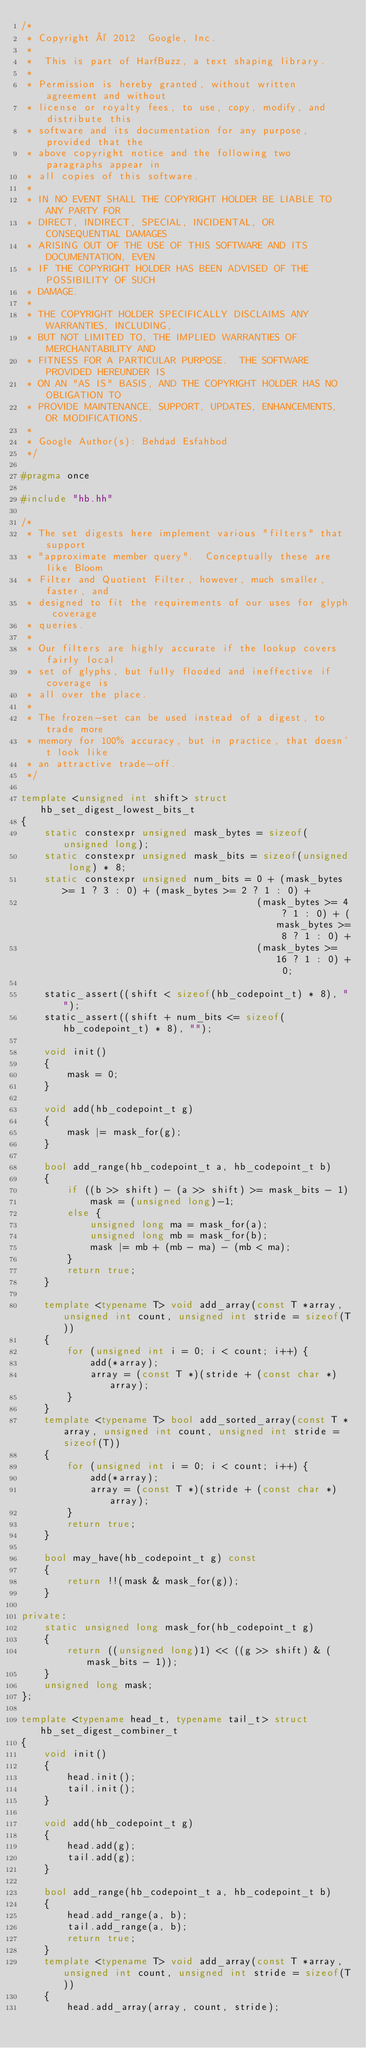Convert code to text. <code><loc_0><loc_0><loc_500><loc_500><_C++_>/*
 * Copyright © 2012  Google, Inc.
 *
 *  This is part of HarfBuzz, a text shaping library.
 *
 * Permission is hereby granted, without written agreement and without
 * license or royalty fees, to use, copy, modify, and distribute this
 * software and its documentation for any purpose, provided that the
 * above copyright notice and the following two paragraphs appear in
 * all copies of this software.
 *
 * IN NO EVENT SHALL THE COPYRIGHT HOLDER BE LIABLE TO ANY PARTY FOR
 * DIRECT, INDIRECT, SPECIAL, INCIDENTAL, OR CONSEQUENTIAL DAMAGES
 * ARISING OUT OF THE USE OF THIS SOFTWARE AND ITS DOCUMENTATION, EVEN
 * IF THE COPYRIGHT HOLDER HAS BEEN ADVISED OF THE POSSIBILITY OF SUCH
 * DAMAGE.
 *
 * THE COPYRIGHT HOLDER SPECIFICALLY DISCLAIMS ANY WARRANTIES, INCLUDING,
 * BUT NOT LIMITED TO, THE IMPLIED WARRANTIES OF MERCHANTABILITY AND
 * FITNESS FOR A PARTICULAR PURPOSE.  THE SOFTWARE PROVIDED HEREUNDER IS
 * ON AN "AS IS" BASIS, AND THE COPYRIGHT HOLDER HAS NO OBLIGATION TO
 * PROVIDE MAINTENANCE, SUPPORT, UPDATES, ENHANCEMENTS, OR MODIFICATIONS.
 *
 * Google Author(s): Behdad Esfahbod
 */

#pragma once

#include "hb.hh"

/*
 * The set digests here implement various "filters" that support
 * "approximate member query".  Conceptually these are like Bloom
 * Filter and Quotient Filter, however, much smaller, faster, and
 * designed to fit the requirements of our uses for glyph coverage
 * queries.
 *
 * Our filters are highly accurate if the lookup covers fairly local
 * set of glyphs, but fully flooded and ineffective if coverage is
 * all over the place.
 *
 * The frozen-set can be used instead of a digest, to trade more
 * memory for 100% accuracy, but in practice, that doesn't look like
 * an attractive trade-off.
 */

template <unsigned int shift> struct hb_set_digest_lowest_bits_t
{
    static constexpr unsigned mask_bytes = sizeof(unsigned long);
    static constexpr unsigned mask_bits = sizeof(unsigned long) * 8;
    static constexpr unsigned num_bits = 0 + (mask_bytes >= 1 ? 3 : 0) + (mask_bytes >= 2 ? 1 : 0) +
                                         (mask_bytes >= 4 ? 1 : 0) + (mask_bytes >= 8 ? 1 : 0) +
                                         (mask_bytes >= 16 ? 1 : 0) + 0;

    static_assert((shift < sizeof(hb_codepoint_t) * 8), "");
    static_assert((shift + num_bits <= sizeof(hb_codepoint_t) * 8), "");

    void init()
    {
        mask = 0;
    }

    void add(hb_codepoint_t g)
    {
        mask |= mask_for(g);
    }

    bool add_range(hb_codepoint_t a, hb_codepoint_t b)
    {
        if ((b >> shift) - (a >> shift) >= mask_bits - 1)
            mask = (unsigned long)-1;
        else {
            unsigned long ma = mask_for(a);
            unsigned long mb = mask_for(b);
            mask |= mb + (mb - ma) - (mb < ma);
        }
        return true;
    }

    template <typename T> void add_array(const T *array, unsigned int count, unsigned int stride = sizeof(T))
    {
        for (unsigned int i = 0; i < count; i++) {
            add(*array);
            array = (const T *)(stride + (const char *)array);
        }
    }
    template <typename T> bool add_sorted_array(const T *array, unsigned int count, unsigned int stride = sizeof(T))
    {
        for (unsigned int i = 0; i < count; i++) {
            add(*array);
            array = (const T *)(stride + (const char *)array);
        }
        return true;
    }

    bool may_have(hb_codepoint_t g) const
    {
        return !!(mask & mask_for(g));
    }

private:
    static unsigned long mask_for(hb_codepoint_t g)
    {
        return ((unsigned long)1) << ((g >> shift) & (mask_bits - 1));
    }
    unsigned long mask;
};

template <typename head_t, typename tail_t> struct hb_set_digest_combiner_t
{
    void init()
    {
        head.init();
        tail.init();
    }

    void add(hb_codepoint_t g)
    {
        head.add(g);
        tail.add(g);
    }

    bool add_range(hb_codepoint_t a, hb_codepoint_t b)
    {
        head.add_range(a, b);
        tail.add_range(a, b);
        return true;
    }
    template <typename T> void add_array(const T *array, unsigned int count, unsigned int stride = sizeof(T))
    {
        head.add_array(array, count, stride);</code> 